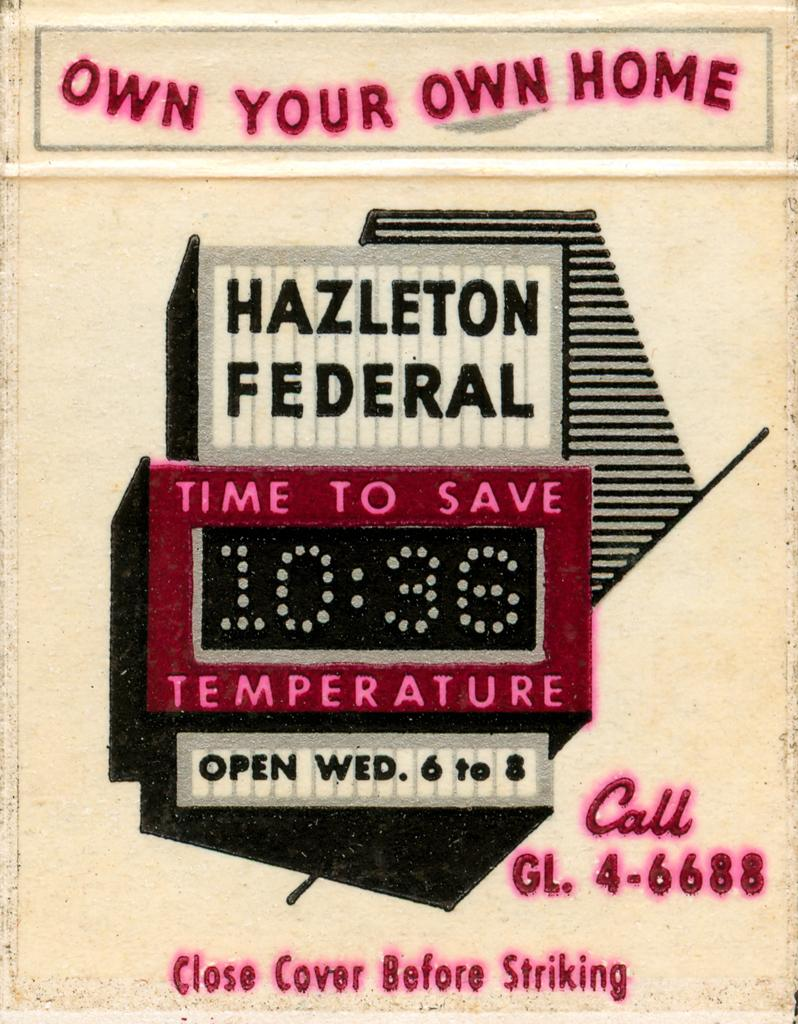<image>
Write a terse but informative summary of the picture. A poster if our own home that says they open on Wed. 6 to 8. 